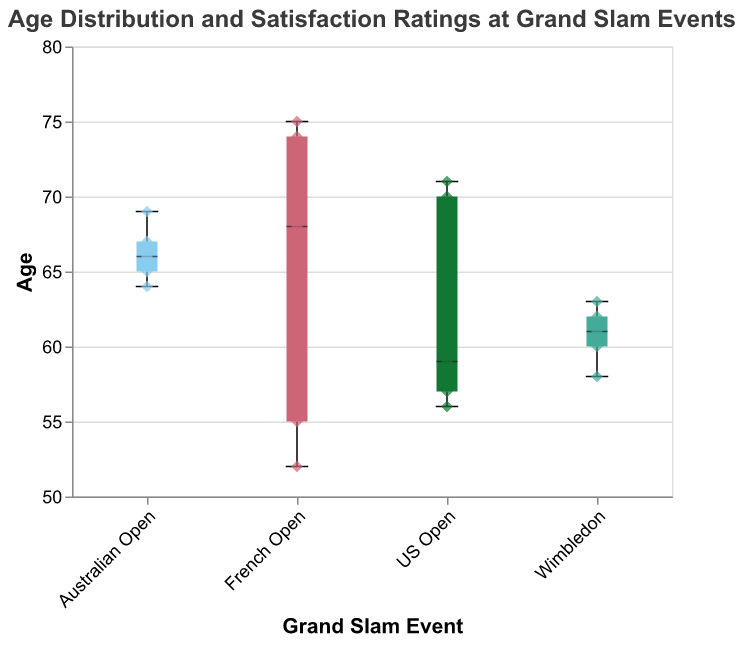what is the median age of attendees at the Australian Open? The median age of attendees for each event is represented by the thick line within the box of the box plot. For the Australian Open, the median age line lies at 66.
Answer: 66 what is the range of satisfaction ratings for attendees of the French Open? The satisfaction ratings are shown by scatter points in the box plot. For the French Open, the satisfaction ratings range from 6 to 9.
Answer: 6 to 9 which event has the highest maximum age of attendees? By looking at the top whisker of each box plot, we can see that the French Open has the highest maximum age, which is 75.
Answer: French Open how many data points are there for the US Open? Counting the scatter points corresponding to the US Open event, there are 5 data points.
Answer: 5 which event has the youngest median age of attendees? The youngest median age is represented by the thick line within each box plot. The French Open has the lowest median age, which lies at 59.
Answer: French Open what is the interquartile range (IQR) of ages for attendees of Wimbledon? The interquartile range is represented by the box itself, stretching from the lower quartile to the upper quartile. For Wimbledon, the lower quartile is at 58 and the upper quartile is at 62, making the IQR 62 - 58 = 4.
Answer: 4 how does the satisfaction rating vary with age for the French Open? The scatter points in the French Open box plot show that the satisfaction rating generally decreases as age increases. Higher satisfaction ratings of 8 and 9 are seen for younger attendees, while lower ratings of 6 are seen for older attendees.
Answer: Decreases with age what is the average age of attendees at the US Open? The ages are 70, 56, 71, 57, and 59. Sum up the ages: 70 + 56 + 71 + 57 + 59 = 313. Then divide by the number of attendees: 313/5 = 62.6.
Answer: 62.6 which event has the largest spread in the data? The spread can be determined by looking at the total length of the whiskers and box combined. The French Open, with ages ranging from 52 to 75, has the largest spread.
Answer: French Open 